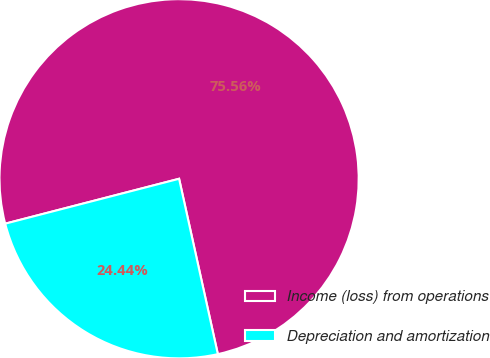Convert chart to OTSL. <chart><loc_0><loc_0><loc_500><loc_500><pie_chart><fcel>Income (loss) from operations<fcel>Depreciation and amortization<nl><fcel>75.56%<fcel>24.44%<nl></chart> 